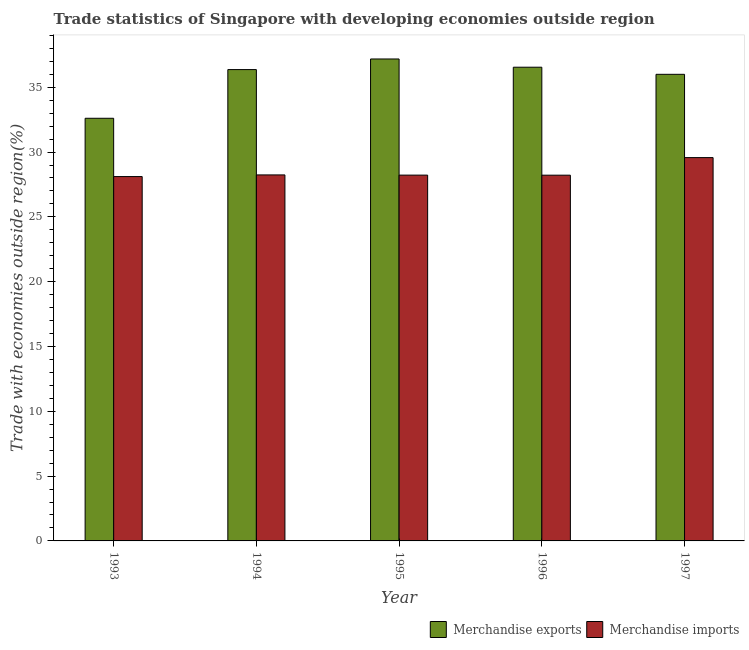Are the number of bars on each tick of the X-axis equal?
Make the answer very short. Yes. How many bars are there on the 1st tick from the left?
Keep it short and to the point. 2. How many bars are there on the 2nd tick from the right?
Your response must be concise. 2. In how many cases, is the number of bars for a given year not equal to the number of legend labels?
Your answer should be compact. 0. What is the merchandise imports in 1996?
Provide a succinct answer. 28.22. Across all years, what is the maximum merchandise exports?
Your answer should be very brief. 37.18. Across all years, what is the minimum merchandise exports?
Your response must be concise. 32.61. In which year was the merchandise exports minimum?
Offer a terse response. 1993. What is the total merchandise exports in the graph?
Give a very brief answer. 178.69. What is the difference between the merchandise exports in 1993 and that in 1997?
Offer a very short reply. -3.39. What is the difference between the merchandise exports in 1994 and the merchandise imports in 1995?
Provide a succinct answer. -0.82. What is the average merchandise imports per year?
Give a very brief answer. 28.47. What is the ratio of the merchandise imports in 1993 to that in 1997?
Make the answer very short. 0.95. Is the merchandise imports in 1993 less than that in 1995?
Your response must be concise. Yes. What is the difference between the highest and the second highest merchandise imports?
Your response must be concise. 1.34. What is the difference between the highest and the lowest merchandise exports?
Give a very brief answer. 4.57. In how many years, is the merchandise imports greater than the average merchandise imports taken over all years?
Provide a succinct answer. 1. How many bars are there?
Offer a terse response. 10. Are all the bars in the graph horizontal?
Your answer should be very brief. No. What is the difference between two consecutive major ticks on the Y-axis?
Your answer should be very brief. 5. How many legend labels are there?
Offer a terse response. 2. What is the title of the graph?
Offer a very short reply. Trade statistics of Singapore with developing economies outside region. What is the label or title of the Y-axis?
Your answer should be compact. Trade with economies outside region(%). What is the Trade with economies outside region(%) of Merchandise exports in 1993?
Your response must be concise. 32.61. What is the Trade with economies outside region(%) of Merchandise imports in 1993?
Give a very brief answer. 28.11. What is the Trade with economies outside region(%) of Merchandise exports in 1994?
Ensure brevity in your answer.  36.36. What is the Trade with economies outside region(%) in Merchandise imports in 1994?
Offer a terse response. 28.24. What is the Trade with economies outside region(%) of Merchandise exports in 1995?
Offer a terse response. 37.18. What is the Trade with economies outside region(%) in Merchandise imports in 1995?
Provide a short and direct response. 28.22. What is the Trade with economies outside region(%) in Merchandise exports in 1996?
Your answer should be compact. 36.55. What is the Trade with economies outside region(%) of Merchandise imports in 1996?
Your answer should be very brief. 28.22. What is the Trade with economies outside region(%) of Merchandise exports in 1997?
Your response must be concise. 36. What is the Trade with economies outside region(%) of Merchandise imports in 1997?
Make the answer very short. 29.57. Across all years, what is the maximum Trade with economies outside region(%) in Merchandise exports?
Your response must be concise. 37.18. Across all years, what is the maximum Trade with economies outside region(%) in Merchandise imports?
Provide a succinct answer. 29.57. Across all years, what is the minimum Trade with economies outside region(%) in Merchandise exports?
Offer a terse response. 32.61. Across all years, what is the minimum Trade with economies outside region(%) in Merchandise imports?
Make the answer very short. 28.11. What is the total Trade with economies outside region(%) in Merchandise exports in the graph?
Provide a short and direct response. 178.69. What is the total Trade with economies outside region(%) of Merchandise imports in the graph?
Make the answer very short. 142.35. What is the difference between the Trade with economies outside region(%) in Merchandise exports in 1993 and that in 1994?
Ensure brevity in your answer.  -3.76. What is the difference between the Trade with economies outside region(%) in Merchandise imports in 1993 and that in 1994?
Your response must be concise. -0.13. What is the difference between the Trade with economies outside region(%) in Merchandise exports in 1993 and that in 1995?
Offer a very short reply. -4.57. What is the difference between the Trade with economies outside region(%) in Merchandise imports in 1993 and that in 1995?
Your answer should be compact. -0.11. What is the difference between the Trade with economies outside region(%) of Merchandise exports in 1993 and that in 1996?
Provide a succinct answer. -3.94. What is the difference between the Trade with economies outside region(%) in Merchandise imports in 1993 and that in 1996?
Ensure brevity in your answer.  -0.11. What is the difference between the Trade with economies outside region(%) of Merchandise exports in 1993 and that in 1997?
Your response must be concise. -3.39. What is the difference between the Trade with economies outside region(%) of Merchandise imports in 1993 and that in 1997?
Provide a short and direct response. -1.46. What is the difference between the Trade with economies outside region(%) in Merchandise exports in 1994 and that in 1995?
Provide a succinct answer. -0.82. What is the difference between the Trade with economies outside region(%) of Merchandise imports in 1994 and that in 1995?
Offer a very short reply. 0.02. What is the difference between the Trade with economies outside region(%) of Merchandise exports in 1994 and that in 1996?
Your answer should be very brief. -0.18. What is the difference between the Trade with economies outside region(%) in Merchandise exports in 1994 and that in 1997?
Your response must be concise. 0.37. What is the difference between the Trade with economies outside region(%) of Merchandise imports in 1994 and that in 1997?
Give a very brief answer. -1.34. What is the difference between the Trade with economies outside region(%) in Merchandise exports in 1995 and that in 1996?
Your answer should be very brief. 0.64. What is the difference between the Trade with economies outside region(%) of Merchandise imports in 1995 and that in 1996?
Ensure brevity in your answer.  0. What is the difference between the Trade with economies outside region(%) in Merchandise exports in 1995 and that in 1997?
Offer a terse response. 1.18. What is the difference between the Trade with economies outside region(%) in Merchandise imports in 1995 and that in 1997?
Your response must be concise. -1.35. What is the difference between the Trade with economies outside region(%) of Merchandise exports in 1996 and that in 1997?
Keep it short and to the point. 0.55. What is the difference between the Trade with economies outside region(%) in Merchandise imports in 1996 and that in 1997?
Offer a very short reply. -1.36. What is the difference between the Trade with economies outside region(%) in Merchandise exports in 1993 and the Trade with economies outside region(%) in Merchandise imports in 1994?
Make the answer very short. 4.37. What is the difference between the Trade with economies outside region(%) of Merchandise exports in 1993 and the Trade with economies outside region(%) of Merchandise imports in 1995?
Provide a succinct answer. 4.39. What is the difference between the Trade with economies outside region(%) of Merchandise exports in 1993 and the Trade with economies outside region(%) of Merchandise imports in 1996?
Your response must be concise. 4.39. What is the difference between the Trade with economies outside region(%) of Merchandise exports in 1993 and the Trade with economies outside region(%) of Merchandise imports in 1997?
Your answer should be compact. 3.03. What is the difference between the Trade with economies outside region(%) of Merchandise exports in 1994 and the Trade with economies outside region(%) of Merchandise imports in 1995?
Your answer should be very brief. 8.14. What is the difference between the Trade with economies outside region(%) of Merchandise exports in 1994 and the Trade with economies outside region(%) of Merchandise imports in 1996?
Your response must be concise. 8.15. What is the difference between the Trade with economies outside region(%) of Merchandise exports in 1994 and the Trade with economies outside region(%) of Merchandise imports in 1997?
Your answer should be very brief. 6.79. What is the difference between the Trade with economies outside region(%) in Merchandise exports in 1995 and the Trade with economies outside region(%) in Merchandise imports in 1996?
Give a very brief answer. 8.96. What is the difference between the Trade with economies outside region(%) in Merchandise exports in 1995 and the Trade with economies outside region(%) in Merchandise imports in 1997?
Your answer should be very brief. 7.61. What is the difference between the Trade with economies outside region(%) of Merchandise exports in 1996 and the Trade with economies outside region(%) of Merchandise imports in 1997?
Ensure brevity in your answer.  6.97. What is the average Trade with economies outside region(%) of Merchandise exports per year?
Your response must be concise. 35.74. What is the average Trade with economies outside region(%) in Merchandise imports per year?
Give a very brief answer. 28.47. In the year 1993, what is the difference between the Trade with economies outside region(%) of Merchandise exports and Trade with economies outside region(%) of Merchandise imports?
Offer a very short reply. 4.5. In the year 1994, what is the difference between the Trade with economies outside region(%) of Merchandise exports and Trade with economies outside region(%) of Merchandise imports?
Offer a terse response. 8.13. In the year 1995, what is the difference between the Trade with economies outside region(%) in Merchandise exports and Trade with economies outside region(%) in Merchandise imports?
Your answer should be very brief. 8.96. In the year 1996, what is the difference between the Trade with economies outside region(%) of Merchandise exports and Trade with economies outside region(%) of Merchandise imports?
Offer a very short reply. 8.33. In the year 1997, what is the difference between the Trade with economies outside region(%) in Merchandise exports and Trade with economies outside region(%) in Merchandise imports?
Your answer should be compact. 6.43. What is the ratio of the Trade with economies outside region(%) of Merchandise exports in 1993 to that in 1994?
Your response must be concise. 0.9. What is the ratio of the Trade with economies outside region(%) of Merchandise imports in 1993 to that in 1994?
Offer a very short reply. 1. What is the ratio of the Trade with economies outside region(%) in Merchandise exports in 1993 to that in 1995?
Offer a terse response. 0.88. What is the ratio of the Trade with economies outside region(%) in Merchandise exports in 1993 to that in 1996?
Your response must be concise. 0.89. What is the ratio of the Trade with economies outside region(%) in Merchandise exports in 1993 to that in 1997?
Provide a succinct answer. 0.91. What is the ratio of the Trade with economies outside region(%) of Merchandise imports in 1993 to that in 1997?
Provide a succinct answer. 0.95. What is the ratio of the Trade with economies outside region(%) in Merchandise imports in 1994 to that in 1995?
Your response must be concise. 1. What is the ratio of the Trade with economies outside region(%) in Merchandise exports in 1994 to that in 1996?
Give a very brief answer. 0.99. What is the ratio of the Trade with economies outside region(%) in Merchandise imports in 1994 to that in 1996?
Offer a terse response. 1. What is the ratio of the Trade with economies outside region(%) of Merchandise imports in 1994 to that in 1997?
Your response must be concise. 0.95. What is the ratio of the Trade with economies outside region(%) in Merchandise exports in 1995 to that in 1996?
Ensure brevity in your answer.  1.02. What is the ratio of the Trade with economies outside region(%) in Merchandise exports in 1995 to that in 1997?
Your response must be concise. 1.03. What is the ratio of the Trade with economies outside region(%) of Merchandise imports in 1995 to that in 1997?
Keep it short and to the point. 0.95. What is the ratio of the Trade with economies outside region(%) in Merchandise exports in 1996 to that in 1997?
Your answer should be very brief. 1.02. What is the ratio of the Trade with economies outside region(%) in Merchandise imports in 1996 to that in 1997?
Keep it short and to the point. 0.95. What is the difference between the highest and the second highest Trade with economies outside region(%) of Merchandise exports?
Keep it short and to the point. 0.64. What is the difference between the highest and the second highest Trade with economies outside region(%) of Merchandise imports?
Your answer should be very brief. 1.34. What is the difference between the highest and the lowest Trade with economies outside region(%) in Merchandise exports?
Offer a terse response. 4.57. What is the difference between the highest and the lowest Trade with economies outside region(%) of Merchandise imports?
Offer a very short reply. 1.46. 